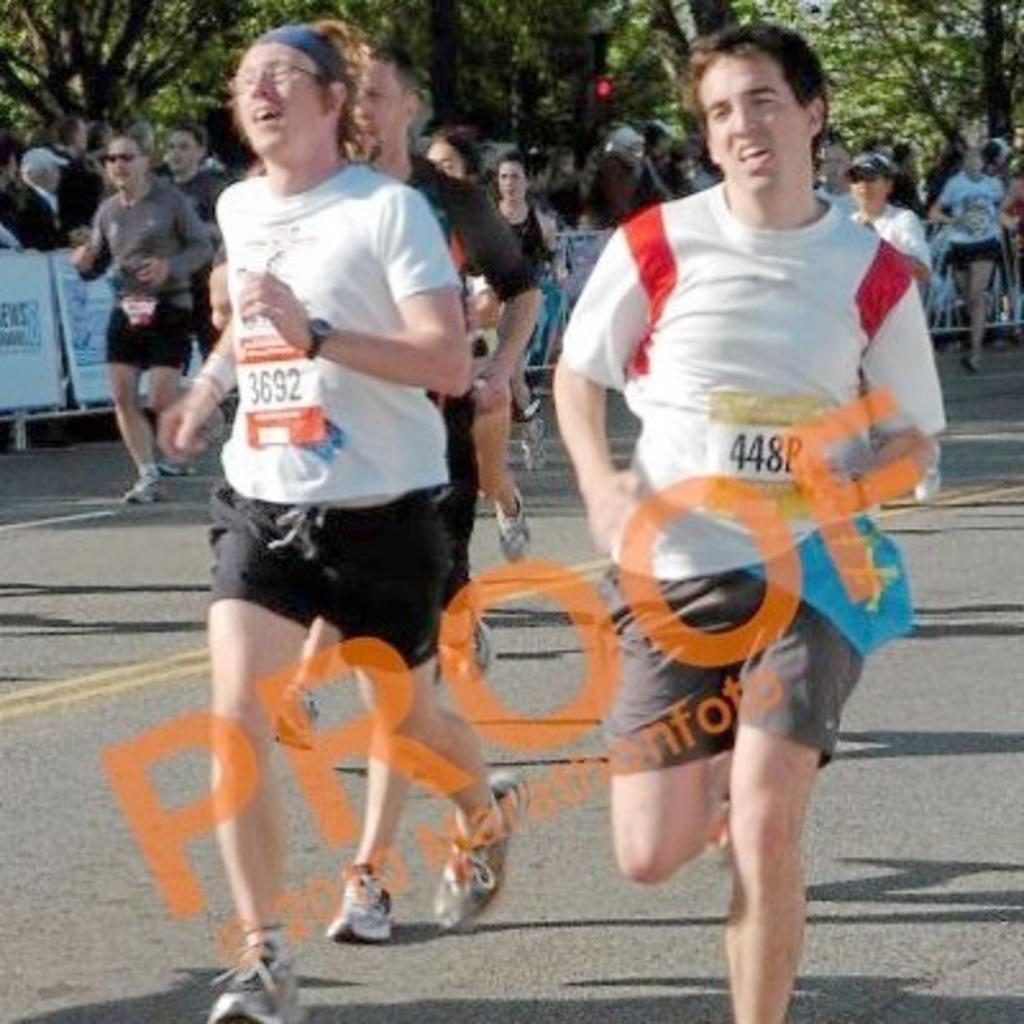Please provide a concise description of this image. In this picture we can see some people are running, there are some people standing in the background, we can see barricades in the middle, we can also see trees in the background, there is a watermark in the middle. 